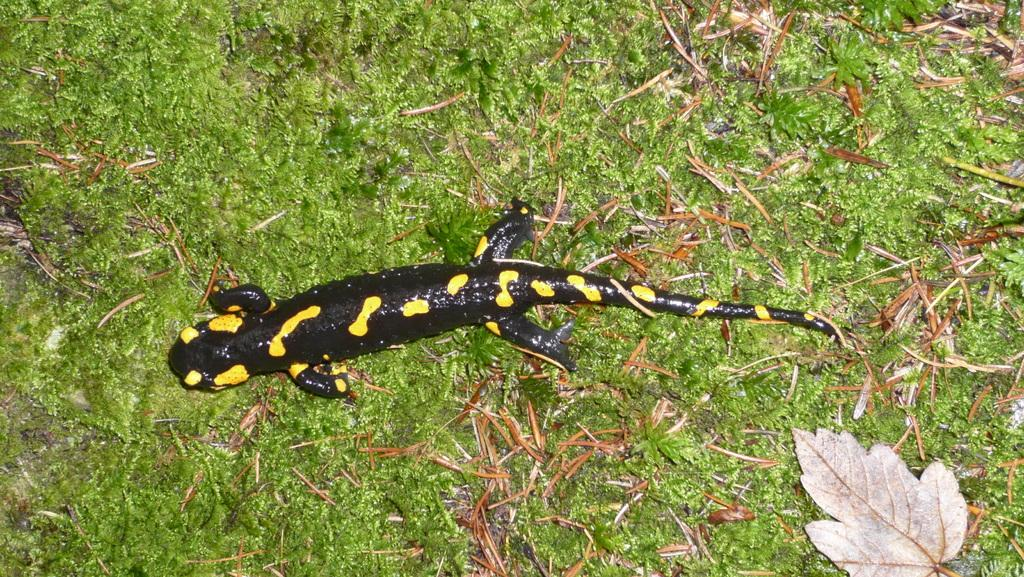What type of animal is in the image? There is a reptile in the image. Where is the reptile located? The reptile is on the grassland. What else can be seen on the ground in the image? There are dried leaves in the image. What type of vegetation is present in the image? There are plants in the image. What type of fruit is hanging from the branches of the trees in the image? There are no trees or fruit present in the image; it only features a reptile on the grassland and dried leaves. 